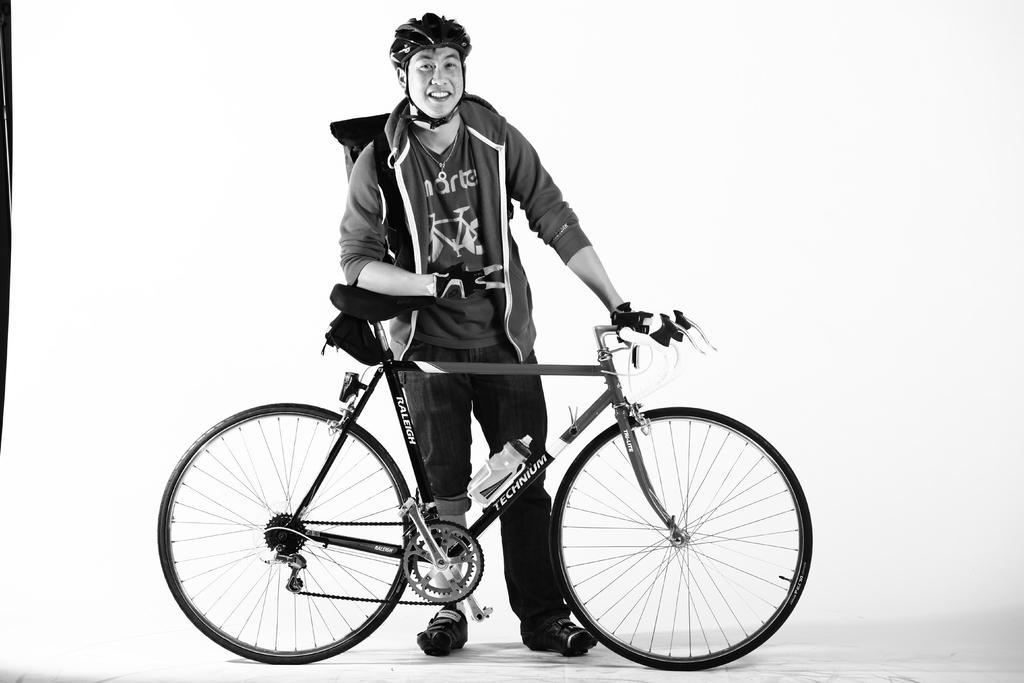Please provide a concise description of this image. This looks like a black and white image. I can see the man standing and holding a bicycle. This is a water bottle, which is fixed to a bicycle. The background looks white in color. 